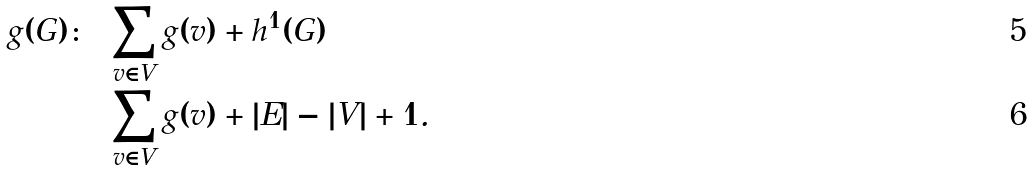<formula> <loc_0><loc_0><loc_500><loc_500>g ( G ) \colon & = \sum _ { v \in V } g ( v ) + h ^ { 1 } ( G ) \\ & = \sum _ { v \in V } g ( v ) + | E | - | V | + 1 .</formula> 